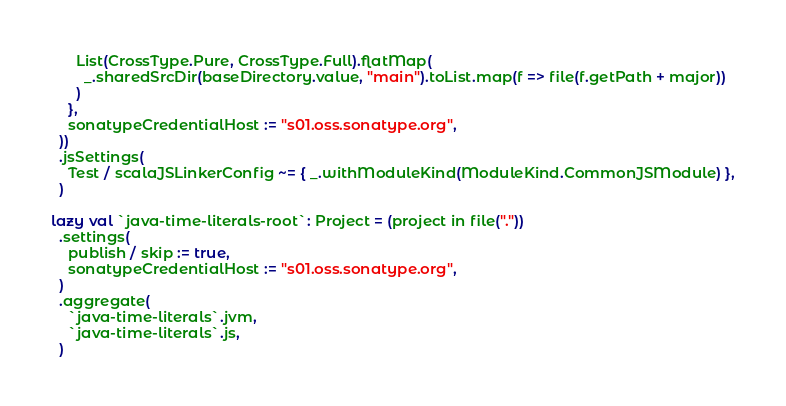<code> <loc_0><loc_0><loc_500><loc_500><_Scala_>      List(CrossType.Pure, CrossType.Full).flatMap(
        _.sharedSrcDir(baseDirectory.value, "main").toList.map(f => file(f.getPath + major))
      )
    },
    sonatypeCredentialHost := "s01.oss.sonatype.org",
  ))
  .jsSettings(
    Test / scalaJSLinkerConfig ~= { _.withModuleKind(ModuleKind.CommonJSModule) },
  )

lazy val `java-time-literals-root`: Project = (project in file("."))
  .settings(
    publish / skip := true,
    sonatypeCredentialHost := "s01.oss.sonatype.org",
  )
  .aggregate(
    `java-time-literals`.jvm,
    `java-time-literals`.js,
  )
</code> 